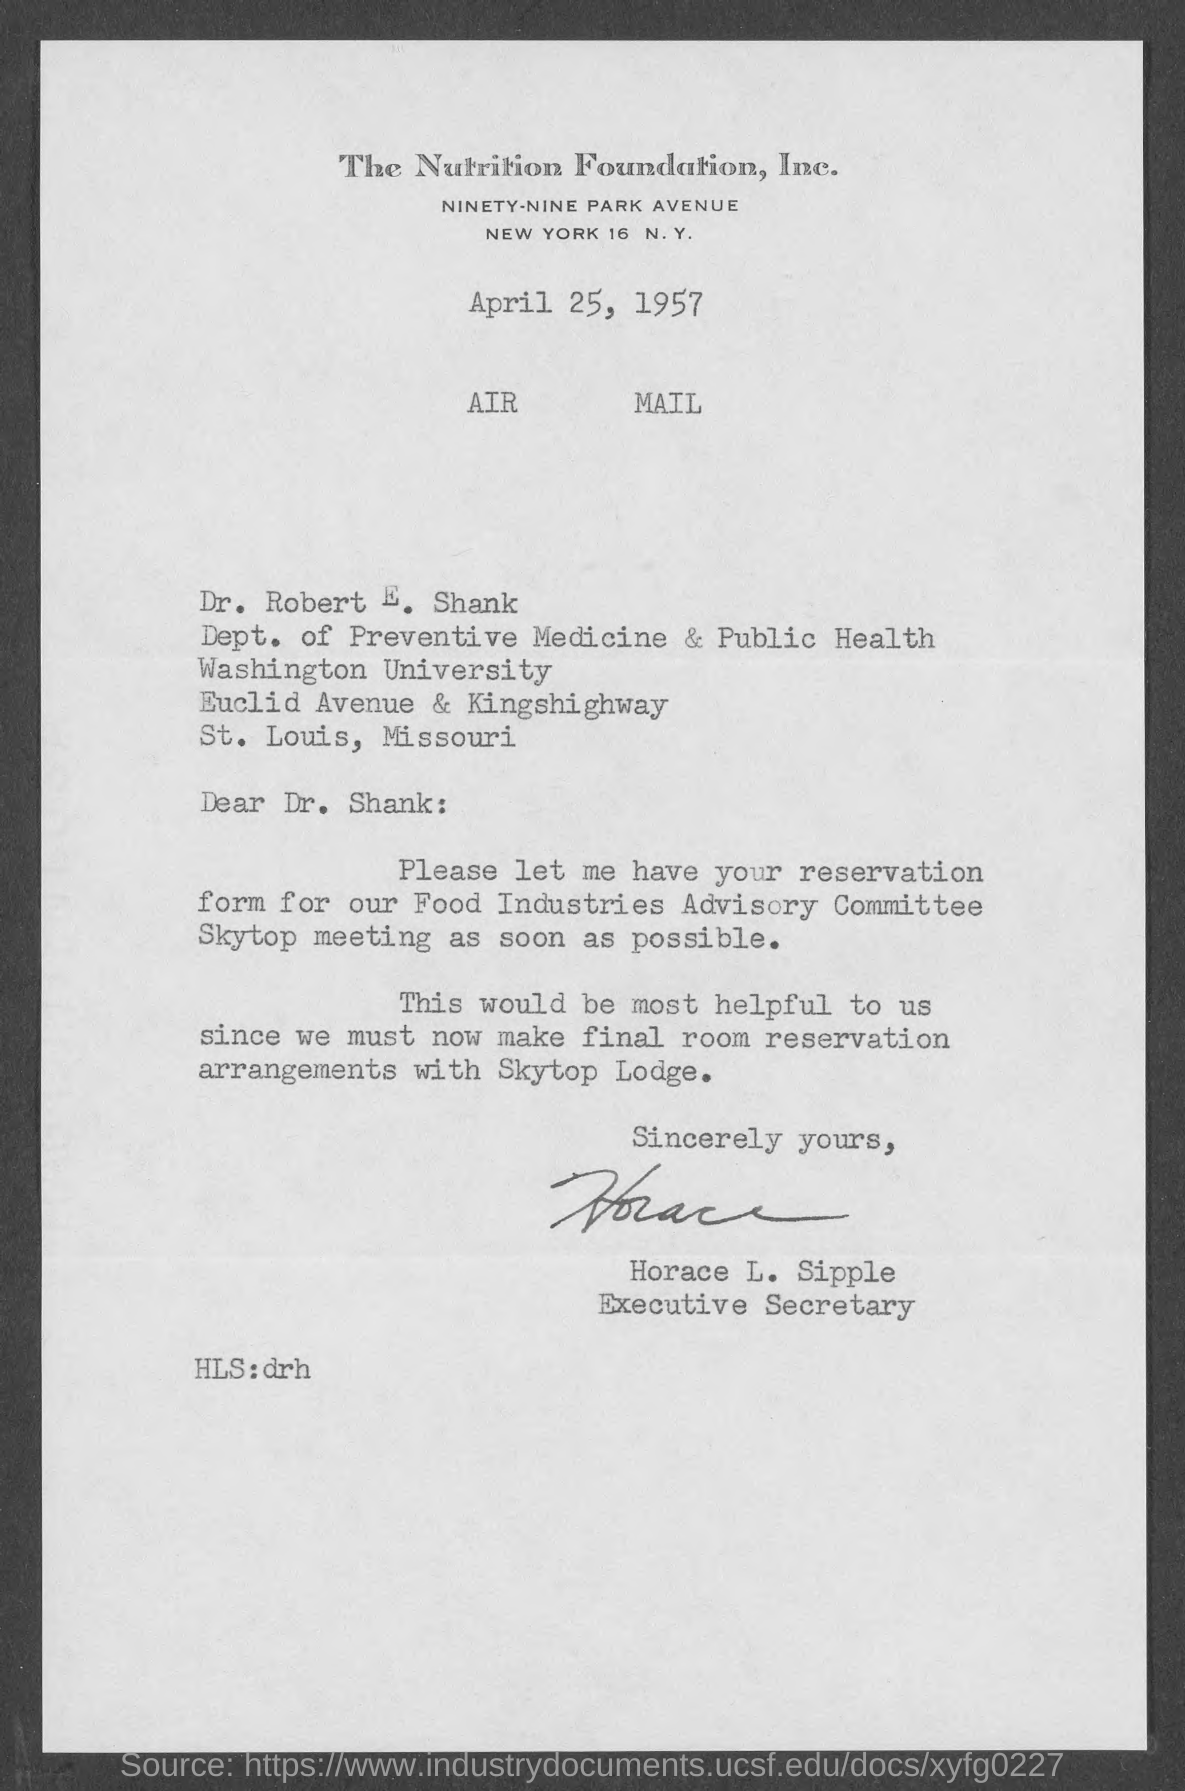What is the Company Name ?
Provide a short and direct response. The Nutrition Foundation, Inc. What is the Date mentioned on the Document ?
Offer a terse response. April 25, 1957. Who is memorandum addressed to ?
Your answer should be very brief. Dr. Robert E. Shank. Who is the executive secretary ?
Provide a short and direct response. Horace L. Sipple. 